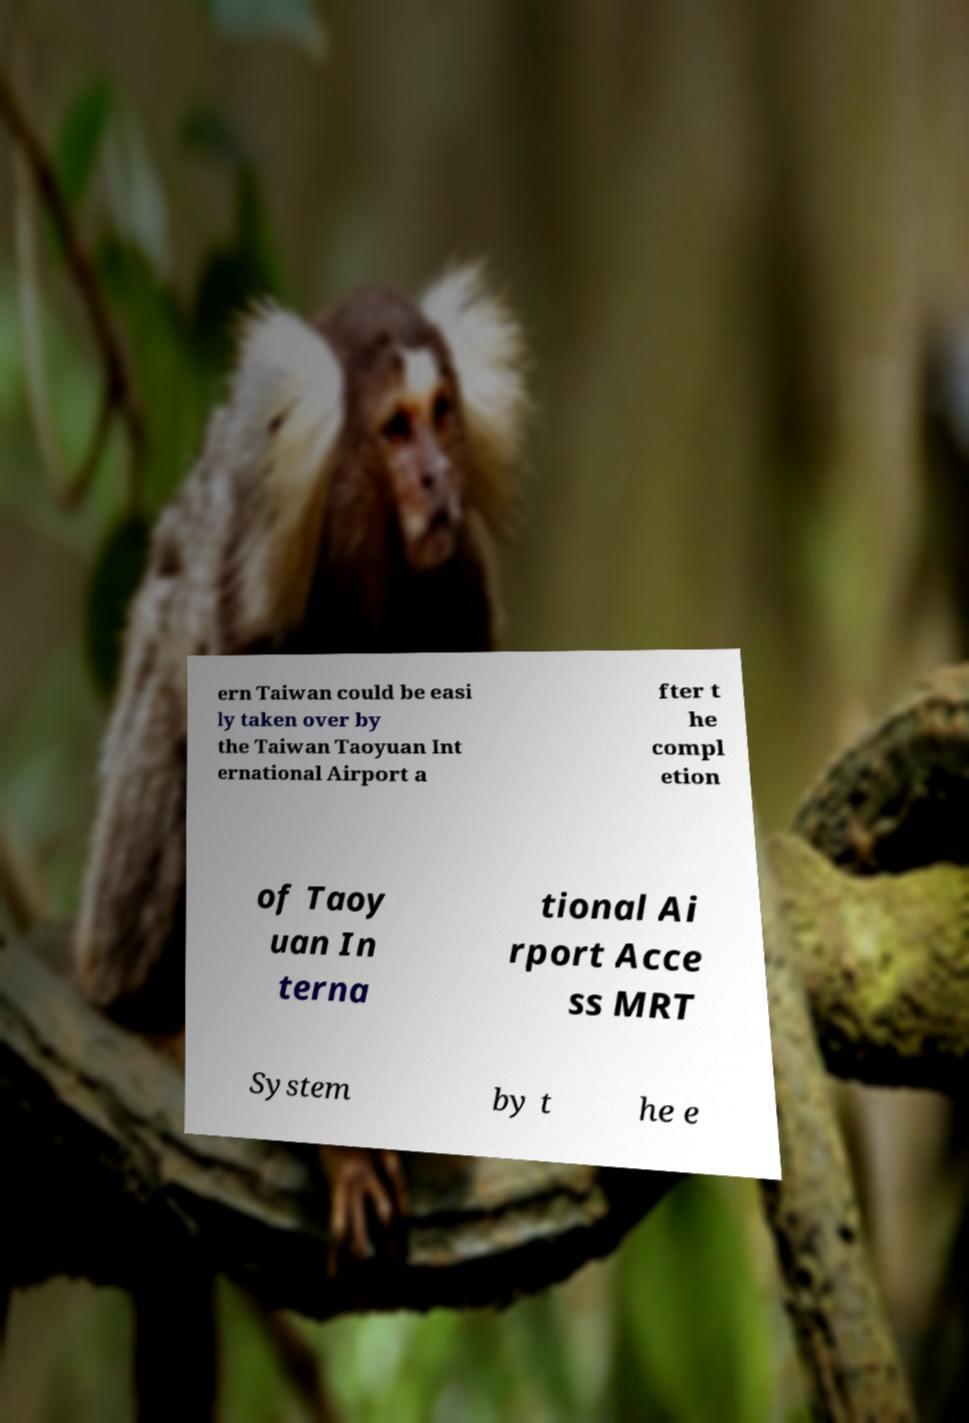Can you accurately transcribe the text from the provided image for me? ern Taiwan could be easi ly taken over by the Taiwan Taoyuan Int ernational Airport a fter t he compl etion of Taoy uan In terna tional Ai rport Acce ss MRT System by t he e 